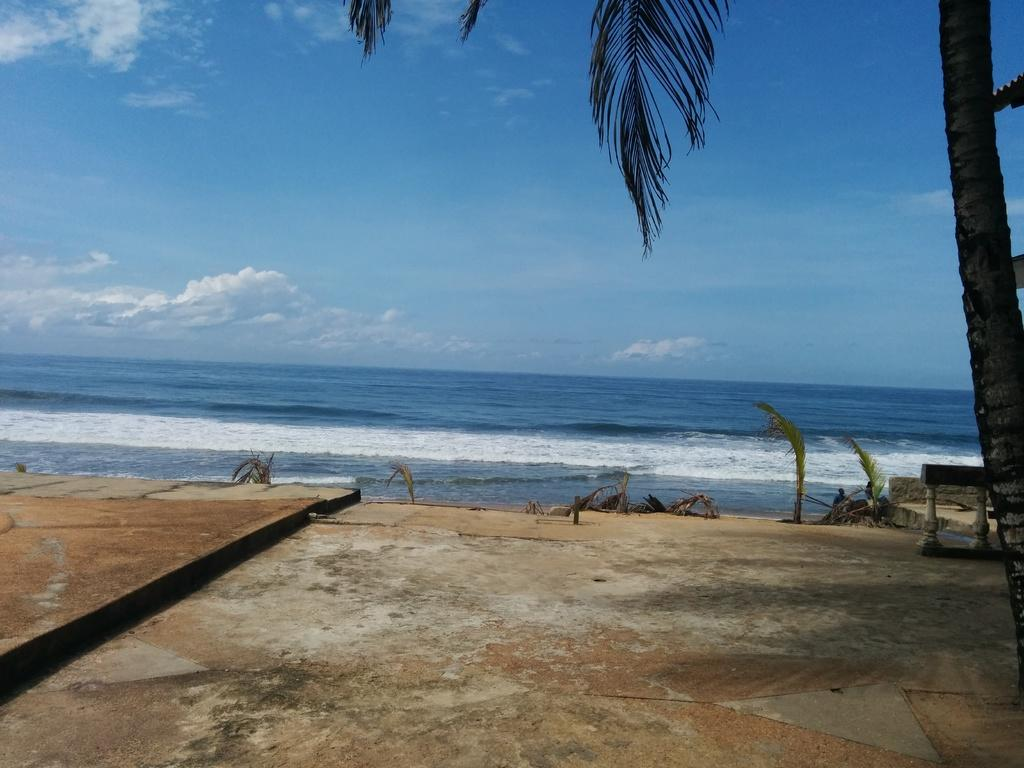What type of landscape is depicted in the image? There is a plain land in the image. What is located in front of the plain land? There is a beach in front of the plain land. Can you describe any specific features on the right side of the image? There is a tall tree on the right side of the image. How much sugar is being used to sweeten the plain land in the image? There is no sugar present in the image, as it is a landscape scene featuring a plain land, a beach, and a tall tree. 